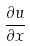<formula> <loc_0><loc_0><loc_500><loc_500>\frac { \partial u } { \partial x }</formula> 